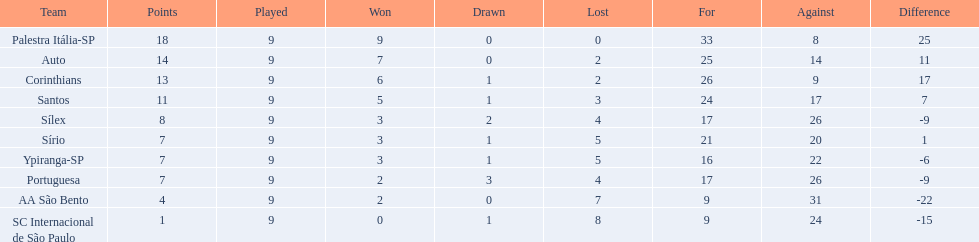How many points were scored by the teams? 18, 14, 13, 11, 8, 7, 7, 7, 4, 1. What team scored 13 points? Corinthians. 